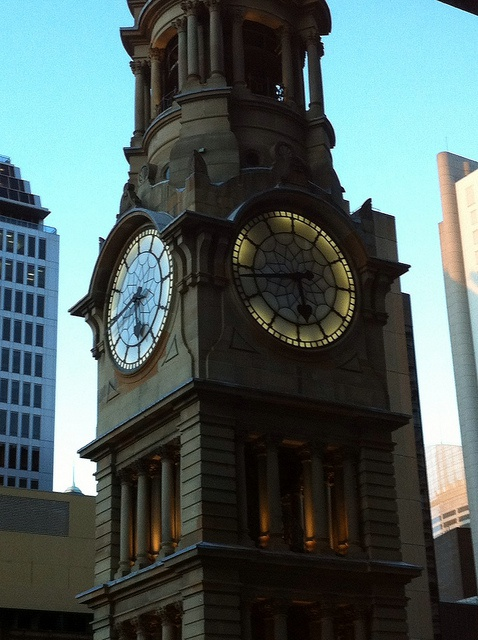Describe the objects in this image and their specific colors. I can see clock in lightblue, black, darkgreen, olive, and gray tones and clock in lightblue, black, gray, and darkgray tones in this image. 